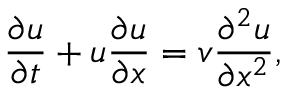<formula> <loc_0><loc_0><loc_500><loc_500>\frac { \partial u } { \partial t } + u \frac { \partial u } { \partial x } = v \frac { \partial ^ { 2 } u } { \partial x ^ { 2 } } ,</formula> 